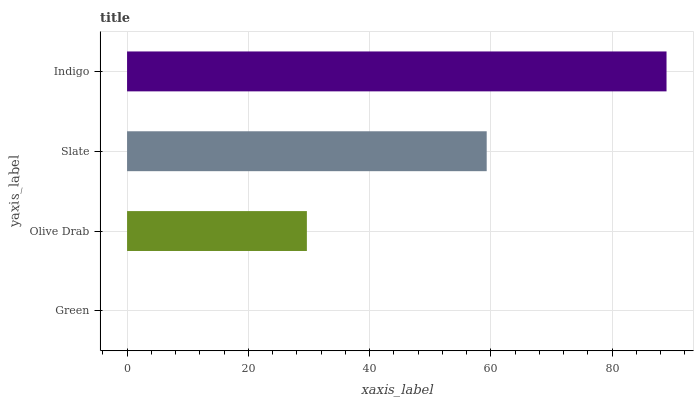Is Green the minimum?
Answer yes or no. Yes. Is Indigo the maximum?
Answer yes or no. Yes. Is Olive Drab the minimum?
Answer yes or no. No. Is Olive Drab the maximum?
Answer yes or no. No. Is Olive Drab greater than Green?
Answer yes or no. Yes. Is Green less than Olive Drab?
Answer yes or no. Yes. Is Green greater than Olive Drab?
Answer yes or no. No. Is Olive Drab less than Green?
Answer yes or no. No. Is Slate the high median?
Answer yes or no. Yes. Is Olive Drab the low median?
Answer yes or no. Yes. Is Olive Drab the high median?
Answer yes or no. No. Is Slate the low median?
Answer yes or no. No. 